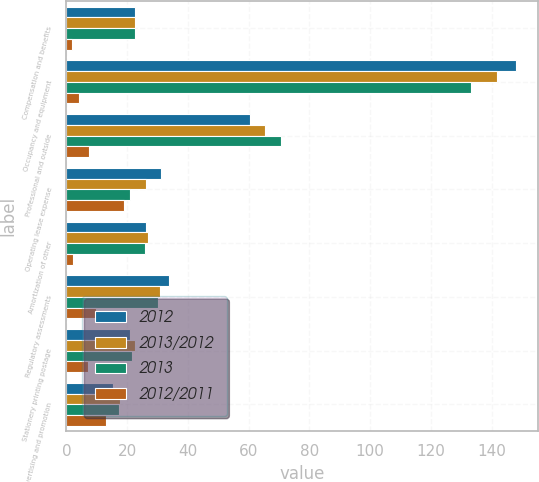<chart> <loc_0><loc_0><loc_500><loc_500><stacked_bar_chart><ecel><fcel>Compensation and benefits<fcel>Occupancy and equipment<fcel>Professional and outside<fcel>Operating lease expense<fcel>Amortization of other<fcel>Regulatory assessments<fcel>Stationery printing postage<fcel>Advertising and promotion<nl><fcel>2012<fcel>22.5<fcel>148<fcel>60.6<fcel>31.3<fcel>26.2<fcel>33.8<fcel>20.9<fcel>15.4<nl><fcel>2013/2012<fcel>22.5<fcel>141.9<fcel>65.4<fcel>26.3<fcel>26.8<fcel>30.8<fcel>22.5<fcel>17.7<nl><fcel>2013<fcel>22.5<fcel>133.3<fcel>70.6<fcel>20.8<fcel>25.8<fcel>30.1<fcel>21.6<fcel>17.2<nl><fcel>2012/2011<fcel>2<fcel>4.3<fcel>7.3<fcel>19<fcel>2.2<fcel>9.7<fcel>7.1<fcel>13<nl></chart> 